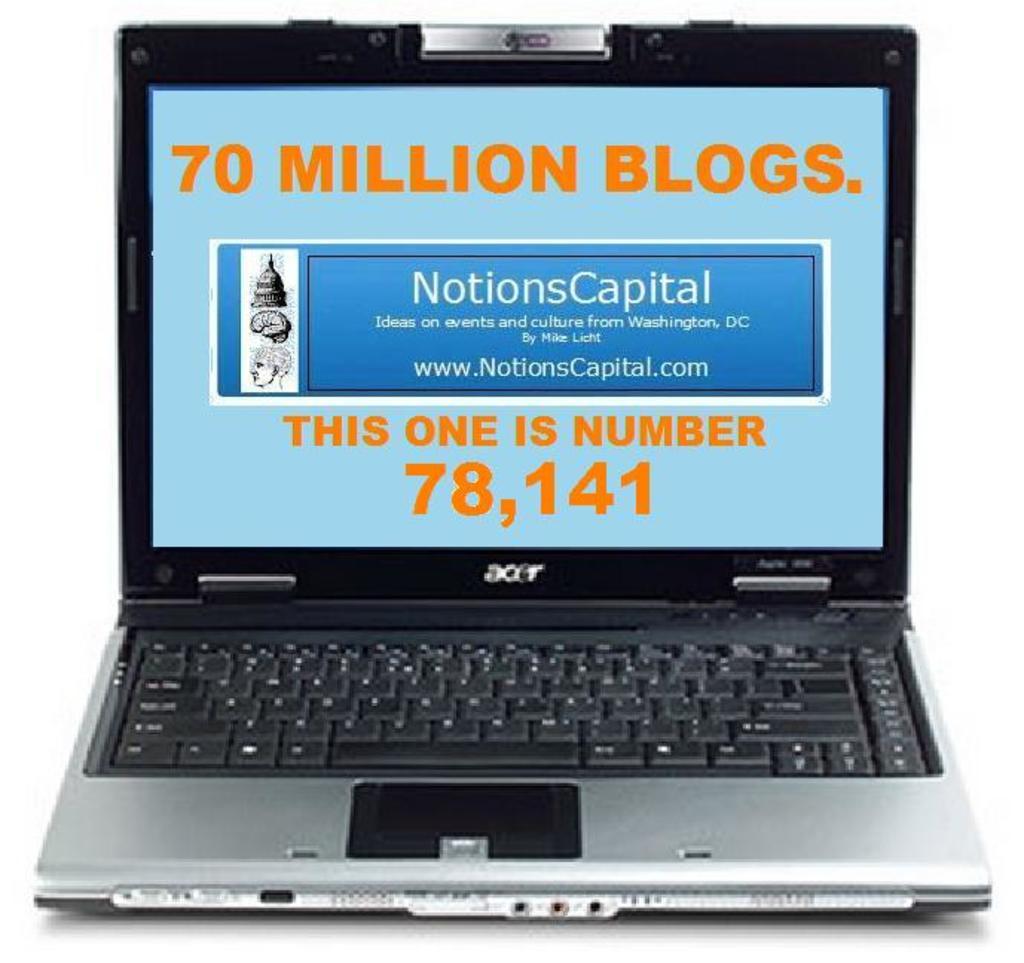How many  blogs are there total?
Provide a short and direct response. 70 million. What number is this blog?
Provide a short and direct response. 78,141. 